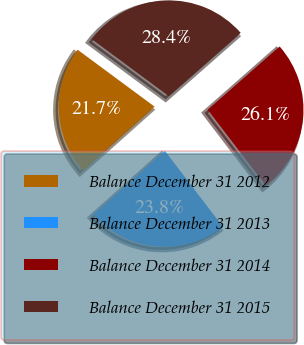<chart> <loc_0><loc_0><loc_500><loc_500><pie_chart><fcel>Balance December 31 2012<fcel>Balance December 31 2013<fcel>Balance December 31 2014<fcel>Balance December 31 2015<nl><fcel>21.73%<fcel>23.79%<fcel>26.1%<fcel>28.39%<nl></chart> 